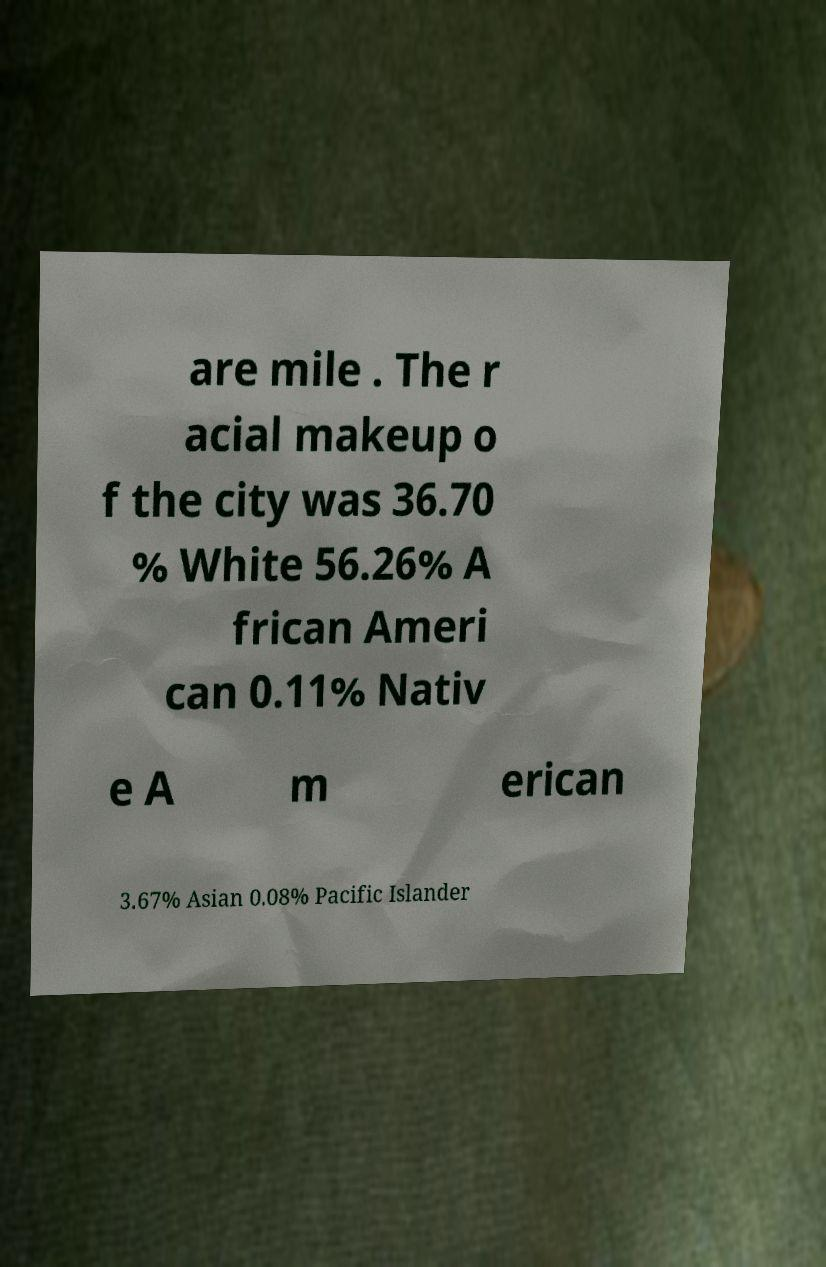I need the written content from this picture converted into text. Can you do that? are mile . The r acial makeup o f the city was 36.70 % White 56.26% A frican Ameri can 0.11% Nativ e A m erican 3.67% Asian 0.08% Pacific Islander 